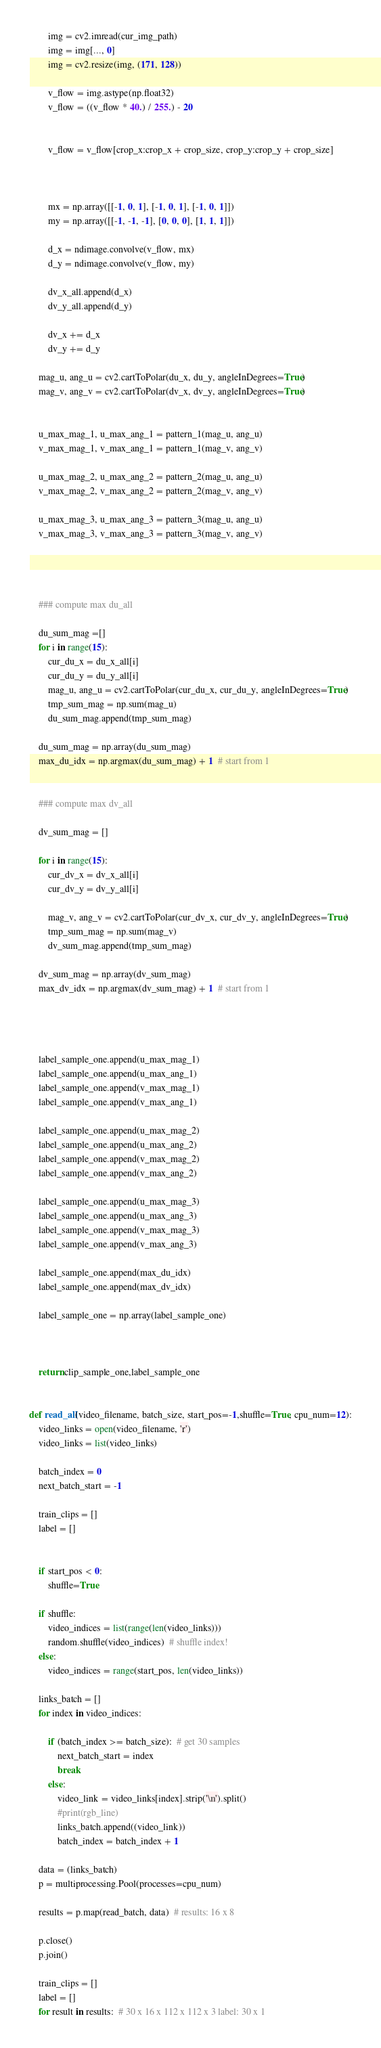<code> <loc_0><loc_0><loc_500><loc_500><_Python_>		img = cv2.imread(cur_img_path)
		img = img[..., 0]
		img = cv2.resize(img, (171, 128))

		v_flow = img.astype(np.float32)
		v_flow = ((v_flow * 40.) / 255.) - 20


		v_flow = v_flow[crop_x:crop_x + crop_size, crop_y:crop_y + crop_size]



		mx = np.array([[-1, 0, 1], [-1, 0, 1], [-1, 0, 1]])
		my = np.array([[-1, -1, -1], [0, 0, 0], [1, 1, 1]])

		d_x = ndimage.convolve(v_flow, mx)
		d_y = ndimage.convolve(v_flow, my)

		dv_x_all.append(d_x)
		dv_y_all.append(d_y)

		dv_x += d_x
		dv_y += d_y

	mag_u, ang_u = cv2.cartToPolar(du_x, du_y, angleInDegrees=True)
	mag_v, ang_v = cv2.cartToPolar(dv_x, dv_y, angleInDegrees=True)


	u_max_mag_1, u_max_ang_1 = pattern_1(mag_u, ang_u)
	v_max_mag_1, v_max_ang_1 = pattern_1(mag_v, ang_v)

	u_max_mag_2, u_max_ang_2 = pattern_2(mag_u, ang_u)
	v_max_mag_2, v_max_ang_2 = pattern_2(mag_v, ang_v)

	u_max_mag_3, u_max_ang_3 = pattern_3(mag_u, ang_u)
	v_max_mag_3, v_max_ang_3 = pattern_3(mag_v, ang_v)




	### compute max du_all

	du_sum_mag =[]
	for i in range(15):
		cur_du_x = du_x_all[i]
		cur_du_y = du_y_all[i]
		mag_u, ang_u = cv2.cartToPolar(cur_du_x, cur_du_y, angleInDegrees=True)
		tmp_sum_mag = np.sum(mag_u)
		du_sum_mag.append(tmp_sum_mag)

	du_sum_mag = np.array(du_sum_mag)
	max_du_idx = np.argmax(du_sum_mag) + 1  # start from 1


	### compute max dv_all

	dv_sum_mag = []

	for i in range(15):
		cur_dv_x = dv_x_all[i]
		cur_dv_y = dv_y_all[i]

		mag_v, ang_v = cv2.cartToPolar(cur_dv_x, cur_dv_y, angleInDegrees=True)
		tmp_sum_mag = np.sum(mag_v)
		dv_sum_mag.append(tmp_sum_mag)

	dv_sum_mag = np.array(dv_sum_mag)
	max_dv_idx = np.argmax(dv_sum_mag) + 1  # start from 1




	label_sample_one.append(u_max_mag_1)
	label_sample_one.append(u_max_ang_1)
	label_sample_one.append(v_max_mag_1)
	label_sample_one.append(v_max_ang_1)

	label_sample_one.append(u_max_mag_2)
	label_sample_one.append(u_max_ang_2)
	label_sample_one.append(v_max_mag_2)
	label_sample_one.append(v_max_ang_2)

	label_sample_one.append(u_max_mag_3)
	label_sample_one.append(u_max_ang_3)
	label_sample_one.append(v_max_mag_3)
	label_sample_one.append(v_max_ang_3)

	label_sample_one.append(max_du_idx)
	label_sample_one.append(max_dv_idx)

	label_sample_one = np.array(label_sample_one)



	return clip_sample_one,label_sample_one


def read_all(video_filename, batch_size, start_pos=-1,shuffle=True, cpu_num=12):
	video_links = open(video_filename, 'r')
	video_links = list(video_links)

	batch_index = 0
	next_batch_start = -1

	train_clips = []
	label = []


    if start_pos < 0:
        shuffle=True

    if shuffle:
        video_indices = list(range(len(video_links)))
        random.shuffle(video_indices)  # shuffle index!
    else:
        video_indices = range(start_pos, len(video_links))

    links_batch = []      
    for index in video_indices:

        if (batch_index >= batch_size):  # get 30 samples
            next_batch_start = index
            break
        else:
            video_link = video_links[index].strip('\n').split()
            #print(rgb_line)
            links_batch.append((video_link))
            batch_index = batch_index + 1

    data = (links_batch)
    p = multiprocessing.Pool(processes=cpu_num)

    results = p.map(read_batch, data)  # results: 16 x 8

    p.close()
    p.join()

    train_clips = []
    label = []
    for result in results:  # 30 x 16 x 112 x 112 x 3 label: 30 x 1</code> 